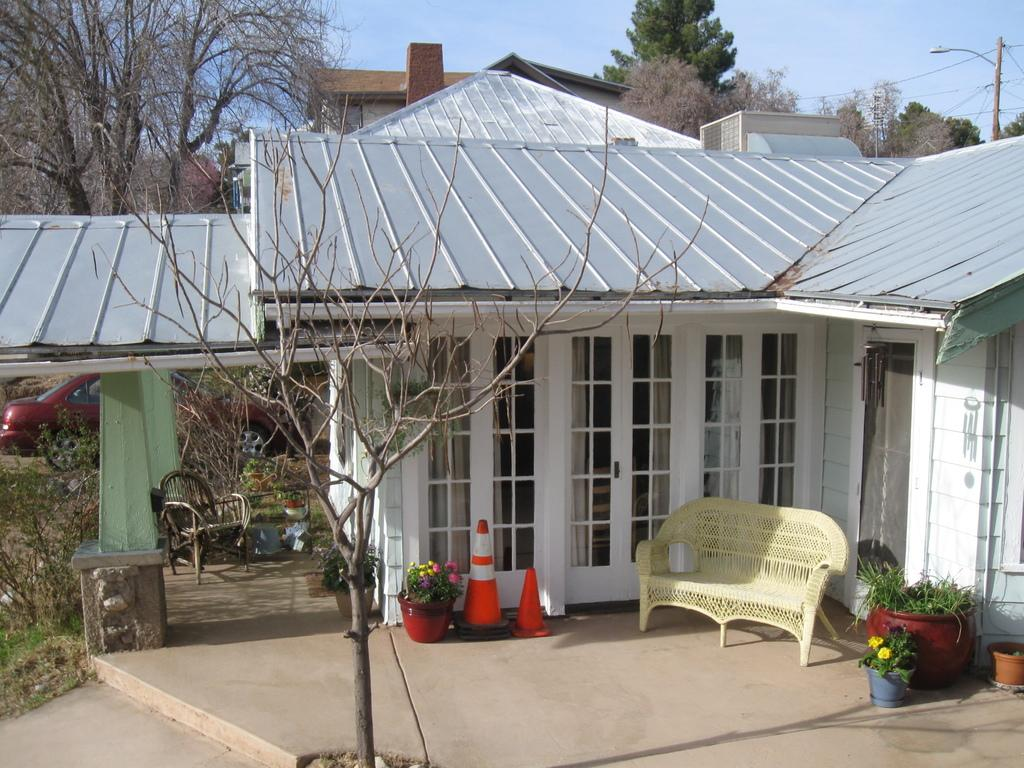What type of building is in the image? There is a house in the image. What is located in front of the house? There is a couch and flower pots in front of the house. What other objects can be seen in front of the house? There are traffic cones in front of the house. What mode of transportation is visible in the image? There is a car in the image. What type of vegetation is present in the image? There are plants visible in the image. What part of the natural environment is visible in the image? The sky is visible in the image. What type of rail can be seen in the image? There is no rail present in the image. 